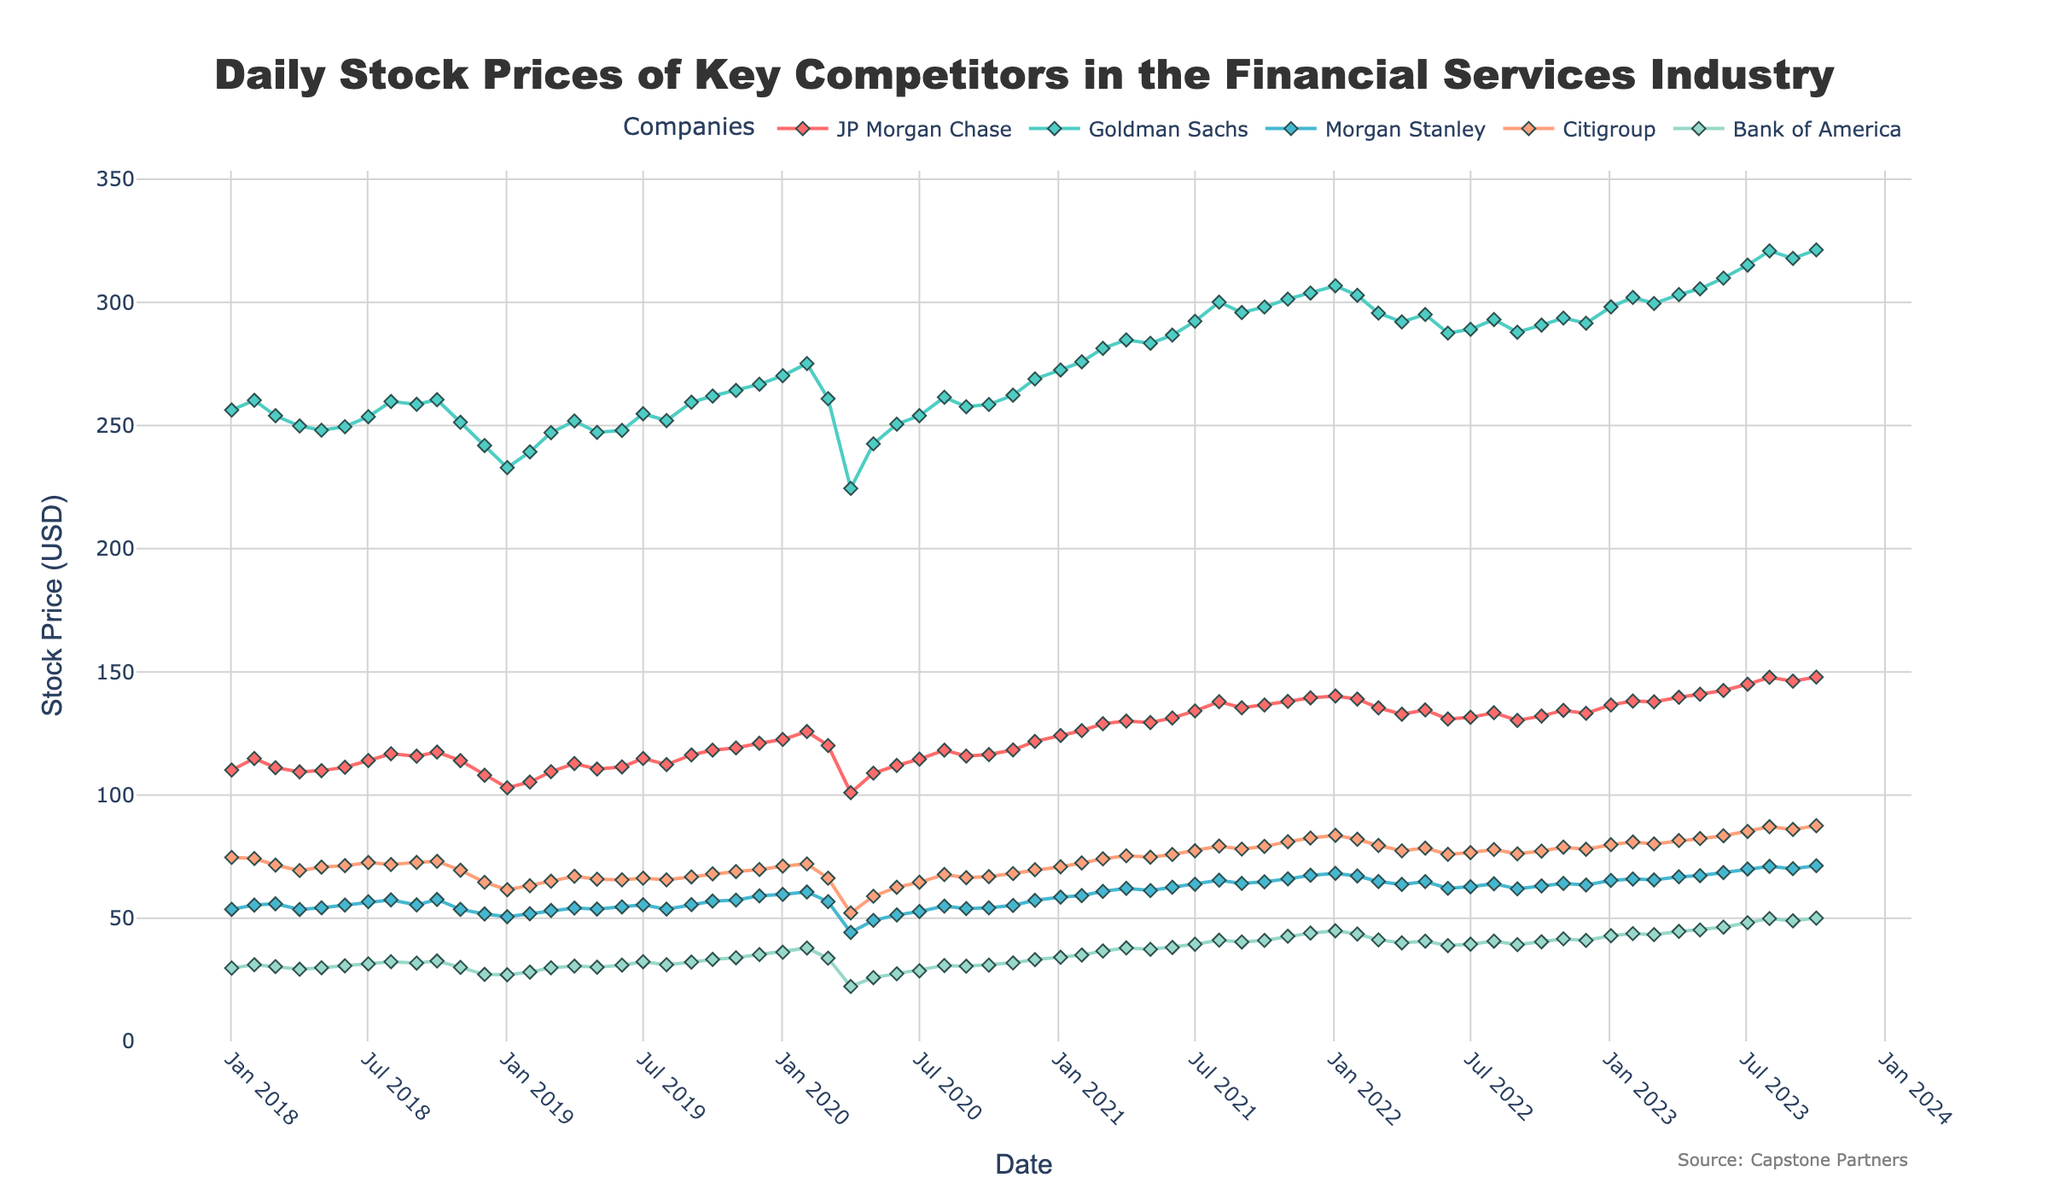What is the title of this figure? The title of a figure is usually located at the top and is clearly written to describe the content of the plot. In this case, we can see the text "Daily Stock Prices of Key Competitors in the Financial Services Industry".
Answer: Daily Stock Prices of Key Competitors in the Financial Services Industry Which competitor had the highest stock price on March 1st, 2022? To find the highest stock price on a specific date, look at the vertical position of the points on that date for each line or marker. In this case, Goldman Sachs had the highest stock price on March 1st, 2022, as its line is positioned highest on the y-axis at that date.
Answer: Goldman Sachs Between which two consecutive months was the largest drop in JP Morgan Chase's stock price observed? Look at the line representing JP Morgan Chase, and identify the largest downward slope between any two adjacent points. The largest drop occurs between February and March 2020.
Answer: February to March 2020 What is the general trend in the stock prices of Goldman Sachs from 2018 to 2023? Examine the entire line for Goldman Sachs from the beginning to the end of the time period. The overall direction indicates if the prices are increasing, decreasing, or remaining stable. Here, the trend shows an increase from 2018 to 2023.
Answer: Increasing Which competitor experienced the smallest fluctuation in their stock prices throughout the 5-year period? To assess stock price fluctuations, look at the range between the highest and lowest points on each competitor's line. Citigroup's line shows the smallest vertical range, indicating the least fluctuation.
Answer: Citigroup What was the stock price of Bank of America in April 2020? Identify the point in the Bank of America line corresponding to April 2020 and read the y-axis value of that point. The stock price is roughly 22.28 USD.
Answer: 22.28 USD During which year did Morgan Stanley's stock price first exceed 60 USD? Focus on the Morgan Stanley line and find the first instance where the price crosses the y-axis value of 60 USD. This occurs in January 2020.
Answer: 2020 How did the stock prices of Citigroup and JP Morgan Chase compare on January 3, 2023? Locate the stock prices for both Citigroup and JP Morgan Chase on the specified date. Citigroup was approximately 79.84 USD, while JP Morgan Chase was about 136.57 USD.
Answer: JP Morgan Chase had a higher stock price What was the average stock price of Bank of America in the year 2021? Sum up the monthly stock prices for Bank of America in 2021 and divide by the number of months (12). The prices are 34.12, 35.04, 36.68, 37.94, 37.36, 38.12, 39.42, 41.08, 40.34, 40.98, 42.68, and 43.96. The average is (450.72 / 12).
Answer: 37.56 USD Which competitor’s stock price saw significant recovery after April 2020? Look at the lines and identify which one shows a steep incline shortly after April 2020. Bank of America's stock price shows a marked recovery.
Answer: Bank of America 